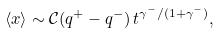<formula> <loc_0><loc_0><loc_500><loc_500>\left < x \right > \sim \mathcal { C } ( q ^ { + } - q ^ { - } ) \, t ^ { \gamma ^ { - } / ( 1 + \gamma ^ { - } ) } ,</formula> 